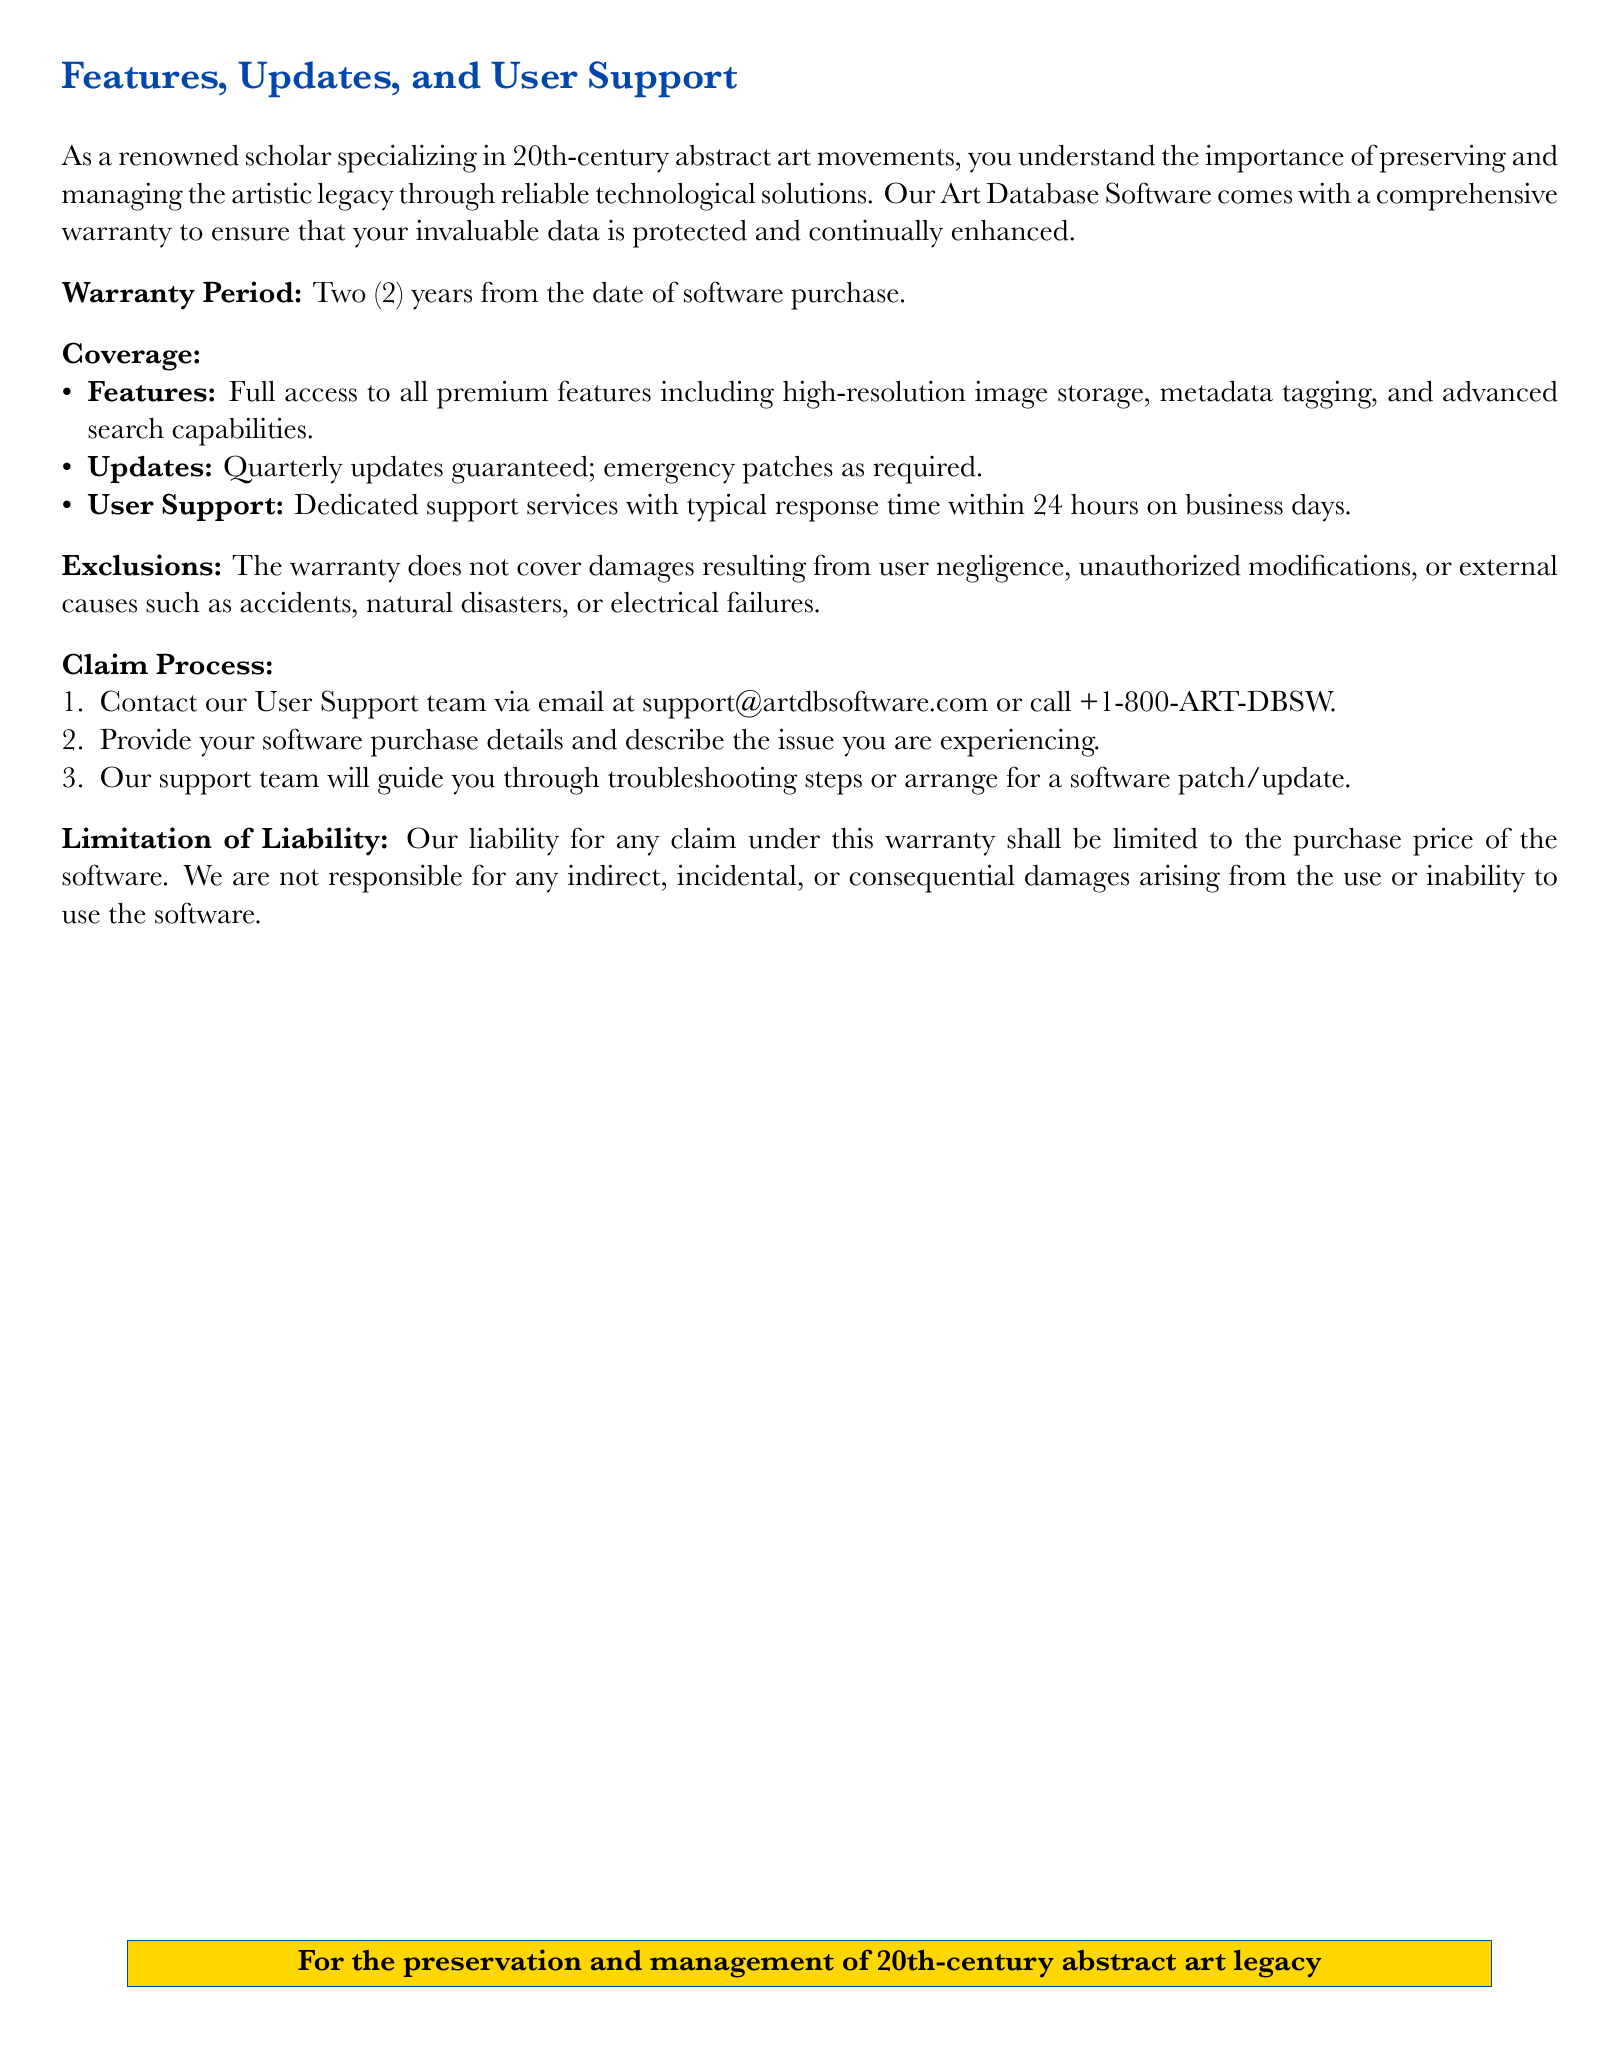What is the warranty period? The warranty period is specified in the document as two years from the date of software purchase.
Answer: Two years What is covered under the warranty? The document lists several aspects that are covered under the warranty, including features and updates.
Answer: Features, Updates, User Support What is the typical response time for user support? The document explicitly states the typical response time for user support inquiries during business days.
Answer: 24 hours What contact methods are provided for user support? The document outlines the methods to contact user support, including email and phone.
Answer: email and phone What types of damages are excluded from the warranty? The document mentions damages not covered and lists specific causes for exclusions.
Answer: User negligence, unauthorized modifications, external causes How often are software updates guaranteed? The document mentions the frequency of guaranteed software updates within the warranty timeline.
Answer: Quarterly What is the limitation of liability stated in the warranty? The document specifies what the liability is limited to in case of claims under the warranty.
Answer: Purchase price What needs to be provided during the claim process? The document describes what users need to provide when contacting support for a warranty claim.
Answer: Software purchase details and issue description What color is used for the title background in the document? The document specifies the background color for the title section as defined.
Answer: Art blue 